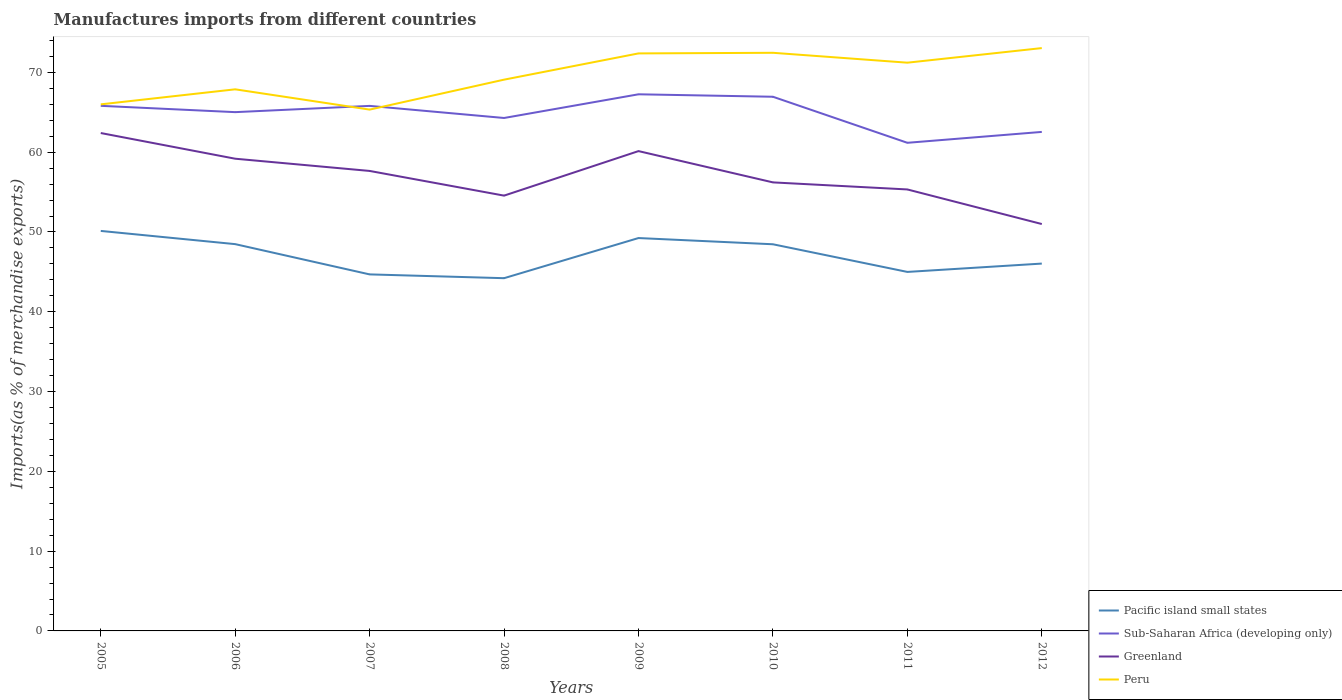Is the number of lines equal to the number of legend labels?
Your response must be concise. Yes. Across all years, what is the maximum percentage of imports to different countries in Greenland?
Offer a very short reply. 51. In which year was the percentage of imports to different countries in Greenland maximum?
Give a very brief answer. 2012. What is the total percentage of imports to different countries in Pacific island small states in the graph?
Provide a short and direct response. -5.03. What is the difference between the highest and the second highest percentage of imports to different countries in Greenland?
Provide a succinct answer. 11.41. How many lines are there?
Your answer should be compact. 4. What is the difference between two consecutive major ticks on the Y-axis?
Your response must be concise. 10. Are the values on the major ticks of Y-axis written in scientific E-notation?
Your response must be concise. No. Does the graph contain any zero values?
Keep it short and to the point. No. Where does the legend appear in the graph?
Make the answer very short. Bottom right. How are the legend labels stacked?
Ensure brevity in your answer.  Vertical. What is the title of the graph?
Give a very brief answer. Manufactures imports from different countries. What is the label or title of the X-axis?
Keep it short and to the point. Years. What is the label or title of the Y-axis?
Your answer should be very brief. Imports(as % of merchandise exports). What is the Imports(as % of merchandise exports) in Pacific island small states in 2005?
Ensure brevity in your answer.  50.13. What is the Imports(as % of merchandise exports) of Sub-Saharan Africa (developing only) in 2005?
Give a very brief answer. 65.81. What is the Imports(as % of merchandise exports) of Greenland in 2005?
Offer a very short reply. 62.4. What is the Imports(as % of merchandise exports) of Peru in 2005?
Provide a succinct answer. 66. What is the Imports(as % of merchandise exports) in Pacific island small states in 2006?
Your response must be concise. 48.48. What is the Imports(as % of merchandise exports) of Sub-Saharan Africa (developing only) in 2006?
Provide a short and direct response. 65.02. What is the Imports(as % of merchandise exports) of Greenland in 2006?
Your answer should be very brief. 59.18. What is the Imports(as % of merchandise exports) in Peru in 2006?
Offer a very short reply. 67.88. What is the Imports(as % of merchandise exports) of Pacific island small states in 2007?
Offer a very short reply. 44.68. What is the Imports(as % of merchandise exports) of Sub-Saharan Africa (developing only) in 2007?
Offer a terse response. 65.8. What is the Imports(as % of merchandise exports) of Greenland in 2007?
Offer a terse response. 57.65. What is the Imports(as % of merchandise exports) in Peru in 2007?
Make the answer very short. 65.34. What is the Imports(as % of merchandise exports) of Pacific island small states in 2008?
Your answer should be compact. 44.21. What is the Imports(as % of merchandise exports) of Sub-Saharan Africa (developing only) in 2008?
Your answer should be compact. 64.29. What is the Imports(as % of merchandise exports) of Greenland in 2008?
Your response must be concise. 54.56. What is the Imports(as % of merchandise exports) of Peru in 2008?
Your answer should be compact. 69.09. What is the Imports(as % of merchandise exports) of Pacific island small states in 2009?
Your answer should be very brief. 49.24. What is the Imports(as % of merchandise exports) of Sub-Saharan Africa (developing only) in 2009?
Ensure brevity in your answer.  67.26. What is the Imports(as % of merchandise exports) of Greenland in 2009?
Offer a terse response. 60.14. What is the Imports(as % of merchandise exports) in Peru in 2009?
Provide a succinct answer. 72.38. What is the Imports(as % of merchandise exports) of Pacific island small states in 2010?
Your answer should be very brief. 48.46. What is the Imports(as % of merchandise exports) in Sub-Saharan Africa (developing only) in 2010?
Provide a succinct answer. 66.95. What is the Imports(as % of merchandise exports) of Greenland in 2010?
Ensure brevity in your answer.  56.22. What is the Imports(as % of merchandise exports) of Peru in 2010?
Provide a succinct answer. 72.46. What is the Imports(as % of merchandise exports) of Pacific island small states in 2011?
Your response must be concise. 44.99. What is the Imports(as % of merchandise exports) of Sub-Saharan Africa (developing only) in 2011?
Keep it short and to the point. 61.18. What is the Imports(as % of merchandise exports) in Greenland in 2011?
Provide a succinct answer. 55.33. What is the Imports(as % of merchandise exports) in Peru in 2011?
Make the answer very short. 71.22. What is the Imports(as % of merchandise exports) in Pacific island small states in 2012?
Give a very brief answer. 46.04. What is the Imports(as % of merchandise exports) in Sub-Saharan Africa (developing only) in 2012?
Your response must be concise. 62.54. What is the Imports(as % of merchandise exports) of Greenland in 2012?
Your answer should be very brief. 51. What is the Imports(as % of merchandise exports) in Peru in 2012?
Give a very brief answer. 73.05. Across all years, what is the maximum Imports(as % of merchandise exports) in Pacific island small states?
Offer a terse response. 50.13. Across all years, what is the maximum Imports(as % of merchandise exports) of Sub-Saharan Africa (developing only)?
Keep it short and to the point. 67.26. Across all years, what is the maximum Imports(as % of merchandise exports) of Greenland?
Make the answer very short. 62.4. Across all years, what is the maximum Imports(as % of merchandise exports) of Peru?
Keep it short and to the point. 73.05. Across all years, what is the minimum Imports(as % of merchandise exports) of Pacific island small states?
Offer a very short reply. 44.21. Across all years, what is the minimum Imports(as % of merchandise exports) of Sub-Saharan Africa (developing only)?
Make the answer very short. 61.18. Across all years, what is the minimum Imports(as % of merchandise exports) of Greenland?
Offer a very short reply. 51. Across all years, what is the minimum Imports(as % of merchandise exports) in Peru?
Your answer should be very brief. 65.34. What is the total Imports(as % of merchandise exports) of Pacific island small states in the graph?
Your response must be concise. 376.24. What is the total Imports(as % of merchandise exports) of Sub-Saharan Africa (developing only) in the graph?
Your response must be concise. 518.85. What is the total Imports(as % of merchandise exports) in Greenland in the graph?
Offer a very short reply. 456.47. What is the total Imports(as % of merchandise exports) of Peru in the graph?
Make the answer very short. 557.41. What is the difference between the Imports(as % of merchandise exports) of Pacific island small states in 2005 and that in 2006?
Ensure brevity in your answer.  1.66. What is the difference between the Imports(as % of merchandise exports) in Sub-Saharan Africa (developing only) in 2005 and that in 2006?
Offer a terse response. 0.79. What is the difference between the Imports(as % of merchandise exports) in Greenland in 2005 and that in 2006?
Give a very brief answer. 3.22. What is the difference between the Imports(as % of merchandise exports) of Peru in 2005 and that in 2006?
Offer a terse response. -1.88. What is the difference between the Imports(as % of merchandise exports) in Pacific island small states in 2005 and that in 2007?
Your answer should be very brief. 5.45. What is the difference between the Imports(as % of merchandise exports) of Sub-Saharan Africa (developing only) in 2005 and that in 2007?
Your answer should be compact. 0.01. What is the difference between the Imports(as % of merchandise exports) in Greenland in 2005 and that in 2007?
Offer a very short reply. 4.75. What is the difference between the Imports(as % of merchandise exports) of Peru in 2005 and that in 2007?
Provide a succinct answer. 0.66. What is the difference between the Imports(as % of merchandise exports) in Pacific island small states in 2005 and that in 2008?
Provide a succinct answer. 5.92. What is the difference between the Imports(as % of merchandise exports) of Sub-Saharan Africa (developing only) in 2005 and that in 2008?
Ensure brevity in your answer.  1.52. What is the difference between the Imports(as % of merchandise exports) of Greenland in 2005 and that in 2008?
Offer a terse response. 7.85. What is the difference between the Imports(as % of merchandise exports) in Peru in 2005 and that in 2008?
Offer a terse response. -3.1. What is the difference between the Imports(as % of merchandise exports) in Pacific island small states in 2005 and that in 2009?
Give a very brief answer. 0.89. What is the difference between the Imports(as % of merchandise exports) in Sub-Saharan Africa (developing only) in 2005 and that in 2009?
Your response must be concise. -1.45. What is the difference between the Imports(as % of merchandise exports) of Greenland in 2005 and that in 2009?
Provide a short and direct response. 2.26. What is the difference between the Imports(as % of merchandise exports) in Peru in 2005 and that in 2009?
Provide a short and direct response. -6.39. What is the difference between the Imports(as % of merchandise exports) of Pacific island small states in 2005 and that in 2010?
Your response must be concise. 1.67. What is the difference between the Imports(as % of merchandise exports) in Sub-Saharan Africa (developing only) in 2005 and that in 2010?
Your response must be concise. -1.14. What is the difference between the Imports(as % of merchandise exports) of Greenland in 2005 and that in 2010?
Your answer should be compact. 6.19. What is the difference between the Imports(as % of merchandise exports) of Peru in 2005 and that in 2010?
Your answer should be very brief. -6.46. What is the difference between the Imports(as % of merchandise exports) of Pacific island small states in 2005 and that in 2011?
Your response must be concise. 5.14. What is the difference between the Imports(as % of merchandise exports) in Sub-Saharan Africa (developing only) in 2005 and that in 2011?
Keep it short and to the point. 4.63. What is the difference between the Imports(as % of merchandise exports) of Greenland in 2005 and that in 2011?
Offer a very short reply. 7.07. What is the difference between the Imports(as % of merchandise exports) in Peru in 2005 and that in 2011?
Give a very brief answer. -5.22. What is the difference between the Imports(as % of merchandise exports) in Pacific island small states in 2005 and that in 2012?
Offer a very short reply. 4.09. What is the difference between the Imports(as % of merchandise exports) in Sub-Saharan Africa (developing only) in 2005 and that in 2012?
Offer a terse response. 3.27. What is the difference between the Imports(as % of merchandise exports) of Greenland in 2005 and that in 2012?
Provide a short and direct response. 11.41. What is the difference between the Imports(as % of merchandise exports) of Peru in 2005 and that in 2012?
Make the answer very short. -7.05. What is the difference between the Imports(as % of merchandise exports) in Pacific island small states in 2006 and that in 2007?
Give a very brief answer. 3.79. What is the difference between the Imports(as % of merchandise exports) in Sub-Saharan Africa (developing only) in 2006 and that in 2007?
Provide a succinct answer. -0.78. What is the difference between the Imports(as % of merchandise exports) of Greenland in 2006 and that in 2007?
Make the answer very short. 1.53. What is the difference between the Imports(as % of merchandise exports) in Peru in 2006 and that in 2007?
Offer a very short reply. 2.54. What is the difference between the Imports(as % of merchandise exports) of Pacific island small states in 2006 and that in 2008?
Your response must be concise. 4.27. What is the difference between the Imports(as % of merchandise exports) in Sub-Saharan Africa (developing only) in 2006 and that in 2008?
Offer a terse response. 0.73. What is the difference between the Imports(as % of merchandise exports) of Greenland in 2006 and that in 2008?
Provide a succinct answer. 4.63. What is the difference between the Imports(as % of merchandise exports) in Peru in 2006 and that in 2008?
Ensure brevity in your answer.  -1.21. What is the difference between the Imports(as % of merchandise exports) in Pacific island small states in 2006 and that in 2009?
Provide a short and direct response. -0.76. What is the difference between the Imports(as % of merchandise exports) of Sub-Saharan Africa (developing only) in 2006 and that in 2009?
Provide a short and direct response. -2.24. What is the difference between the Imports(as % of merchandise exports) in Greenland in 2006 and that in 2009?
Your answer should be very brief. -0.95. What is the difference between the Imports(as % of merchandise exports) in Peru in 2006 and that in 2009?
Offer a very short reply. -4.5. What is the difference between the Imports(as % of merchandise exports) of Pacific island small states in 2006 and that in 2010?
Your answer should be compact. 0.02. What is the difference between the Imports(as % of merchandise exports) of Sub-Saharan Africa (developing only) in 2006 and that in 2010?
Make the answer very short. -1.93. What is the difference between the Imports(as % of merchandise exports) in Greenland in 2006 and that in 2010?
Provide a short and direct response. 2.97. What is the difference between the Imports(as % of merchandise exports) in Peru in 2006 and that in 2010?
Keep it short and to the point. -4.58. What is the difference between the Imports(as % of merchandise exports) of Pacific island small states in 2006 and that in 2011?
Make the answer very short. 3.48. What is the difference between the Imports(as % of merchandise exports) in Sub-Saharan Africa (developing only) in 2006 and that in 2011?
Provide a succinct answer. 3.84. What is the difference between the Imports(as % of merchandise exports) in Greenland in 2006 and that in 2011?
Your answer should be very brief. 3.85. What is the difference between the Imports(as % of merchandise exports) of Peru in 2006 and that in 2011?
Offer a terse response. -3.34. What is the difference between the Imports(as % of merchandise exports) in Pacific island small states in 2006 and that in 2012?
Provide a succinct answer. 2.44. What is the difference between the Imports(as % of merchandise exports) in Sub-Saharan Africa (developing only) in 2006 and that in 2012?
Provide a short and direct response. 2.48. What is the difference between the Imports(as % of merchandise exports) of Greenland in 2006 and that in 2012?
Offer a very short reply. 8.19. What is the difference between the Imports(as % of merchandise exports) of Peru in 2006 and that in 2012?
Your response must be concise. -5.17. What is the difference between the Imports(as % of merchandise exports) of Pacific island small states in 2007 and that in 2008?
Your answer should be very brief. 0.47. What is the difference between the Imports(as % of merchandise exports) of Sub-Saharan Africa (developing only) in 2007 and that in 2008?
Provide a short and direct response. 1.52. What is the difference between the Imports(as % of merchandise exports) in Greenland in 2007 and that in 2008?
Provide a short and direct response. 3.09. What is the difference between the Imports(as % of merchandise exports) of Peru in 2007 and that in 2008?
Offer a very short reply. -3.75. What is the difference between the Imports(as % of merchandise exports) of Pacific island small states in 2007 and that in 2009?
Keep it short and to the point. -4.56. What is the difference between the Imports(as % of merchandise exports) in Sub-Saharan Africa (developing only) in 2007 and that in 2009?
Ensure brevity in your answer.  -1.45. What is the difference between the Imports(as % of merchandise exports) of Greenland in 2007 and that in 2009?
Your answer should be compact. -2.49. What is the difference between the Imports(as % of merchandise exports) of Peru in 2007 and that in 2009?
Offer a terse response. -7.04. What is the difference between the Imports(as % of merchandise exports) in Pacific island small states in 2007 and that in 2010?
Your answer should be compact. -3.78. What is the difference between the Imports(as % of merchandise exports) in Sub-Saharan Africa (developing only) in 2007 and that in 2010?
Your answer should be very brief. -1.14. What is the difference between the Imports(as % of merchandise exports) in Greenland in 2007 and that in 2010?
Your answer should be compact. 1.43. What is the difference between the Imports(as % of merchandise exports) of Peru in 2007 and that in 2010?
Ensure brevity in your answer.  -7.12. What is the difference between the Imports(as % of merchandise exports) in Pacific island small states in 2007 and that in 2011?
Offer a terse response. -0.31. What is the difference between the Imports(as % of merchandise exports) in Sub-Saharan Africa (developing only) in 2007 and that in 2011?
Give a very brief answer. 4.63. What is the difference between the Imports(as % of merchandise exports) in Greenland in 2007 and that in 2011?
Offer a very short reply. 2.32. What is the difference between the Imports(as % of merchandise exports) in Peru in 2007 and that in 2011?
Give a very brief answer. -5.88. What is the difference between the Imports(as % of merchandise exports) of Pacific island small states in 2007 and that in 2012?
Provide a succinct answer. -1.36. What is the difference between the Imports(as % of merchandise exports) of Sub-Saharan Africa (developing only) in 2007 and that in 2012?
Your answer should be compact. 3.26. What is the difference between the Imports(as % of merchandise exports) of Greenland in 2007 and that in 2012?
Your answer should be very brief. 6.65. What is the difference between the Imports(as % of merchandise exports) in Peru in 2007 and that in 2012?
Offer a terse response. -7.71. What is the difference between the Imports(as % of merchandise exports) in Pacific island small states in 2008 and that in 2009?
Keep it short and to the point. -5.03. What is the difference between the Imports(as % of merchandise exports) in Sub-Saharan Africa (developing only) in 2008 and that in 2009?
Provide a short and direct response. -2.97. What is the difference between the Imports(as % of merchandise exports) in Greenland in 2008 and that in 2009?
Offer a very short reply. -5.58. What is the difference between the Imports(as % of merchandise exports) in Peru in 2008 and that in 2009?
Make the answer very short. -3.29. What is the difference between the Imports(as % of merchandise exports) of Pacific island small states in 2008 and that in 2010?
Offer a terse response. -4.25. What is the difference between the Imports(as % of merchandise exports) of Sub-Saharan Africa (developing only) in 2008 and that in 2010?
Provide a succinct answer. -2.66. What is the difference between the Imports(as % of merchandise exports) in Greenland in 2008 and that in 2010?
Give a very brief answer. -1.66. What is the difference between the Imports(as % of merchandise exports) of Peru in 2008 and that in 2010?
Give a very brief answer. -3.37. What is the difference between the Imports(as % of merchandise exports) in Pacific island small states in 2008 and that in 2011?
Make the answer very short. -0.79. What is the difference between the Imports(as % of merchandise exports) of Sub-Saharan Africa (developing only) in 2008 and that in 2011?
Your response must be concise. 3.11. What is the difference between the Imports(as % of merchandise exports) of Greenland in 2008 and that in 2011?
Provide a succinct answer. -0.77. What is the difference between the Imports(as % of merchandise exports) in Peru in 2008 and that in 2011?
Make the answer very short. -2.13. What is the difference between the Imports(as % of merchandise exports) in Pacific island small states in 2008 and that in 2012?
Your response must be concise. -1.83. What is the difference between the Imports(as % of merchandise exports) in Sub-Saharan Africa (developing only) in 2008 and that in 2012?
Ensure brevity in your answer.  1.75. What is the difference between the Imports(as % of merchandise exports) in Greenland in 2008 and that in 2012?
Give a very brief answer. 3.56. What is the difference between the Imports(as % of merchandise exports) of Peru in 2008 and that in 2012?
Provide a short and direct response. -3.96. What is the difference between the Imports(as % of merchandise exports) of Pacific island small states in 2009 and that in 2010?
Your answer should be compact. 0.78. What is the difference between the Imports(as % of merchandise exports) of Sub-Saharan Africa (developing only) in 2009 and that in 2010?
Keep it short and to the point. 0.31. What is the difference between the Imports(as % of merchandise exports) of Greenland in 2009 and that in 2010?
Ensure brevity in your answer.  3.92. What is the difference between the Imports(as % of merchandise exports) of Peru in 2009 and that in 2010?
Make the answer very short. -0.08. What is the difference between the Imports(as % of merchandise exports) of Pacific island small states in 2009 and that in 2011?
Keep it short and to the point. 4.25. What is the difference between the Imports(as % of merchandise exports) in Sub-Saharan Africa (developing only) in 2009 and that in 2011?
Offer a terse response. 6.08. What is the difference between the Imports(as % of merchandise exports) in Greenland in 2009 and that in 2011?
Your response must be concise. 4.81. What is the difference between the Imports(as % of merchandise exports) in Peru in 2009 and that in 2011?
Give a very brief answer. 1.16. What is the difference between the Imports(as % of merchandise exports) of Pacific island small states in 2009 and that in 2012?
Keep it short and to the point. 3.2. What is the difference between the Imports(as % of merchandise exports) of Sub-Saharan Africa (developing only) in 2009 and that in 2012?
Your answer should be very brief. 4.72. What is the difference between the Imports(as % of merchandise exports) in Greenland in 2009 and that in 2012?
Your answer should be very brief. 9.14. What is the difference between the Imports(as % of merchandise exports) in Peru in 2009 and that in 2012?
Offer a terse response. -0.67. What is the difference between the Imports(as % of merchandise exports) of Pacific island small states in 2010 and that in 2011?
Make the answer very short. 3.47. What is the difference between the Imports(as % of merchandise exports) of Sub-Saharan Africa (developing only) in 2010 and that in 2011?
Your answer should be compact. 5.77. What is the difference between the Imports(as % of merchandise exports) in Greenland in 2010 and that in 2011?
Your response must be concise. 0.88. What is the difference between the Imports(as % of merchandise exports) in Peru in 2010 and that in 2011?
Ensure brevity in your answer.  1.24. What is the difference between the Imports(as % of merchandise exports) in Pacific island small states in 2010 and that in 2012?
Ensure brevity in your answer.  2.42. What is the difference between the Imports(as % of merchandise exports) of Sub-Saharan Africa (developing only) in 2010 and that in 2012?
Provide a succinct answer. 4.41. What is the difference between the Imports(as % of merchandise exports) in Greenland in 2010 and that in 2012?
Ensure brevity in your answer.  5.22. What is the difference between the Imports(as % of merchandise exports) in Peru in 2010 and that in 2012?
Give a very brief answer. -0.59. What is the difference between the Imports(as % of merchandise exports) in Pacific island small states in 2011 and that in 2012?
Your answer should be very brief. -1.05. What is the difference between the Imports(as % of merchandise exports) in Sub-Saharan Africa (developing only) in 2011 and that in 2012?
Your answer should be very brief. -1.36. What is the difference between the Imports(as % of merchandise exports) in Greenland in 2011 and that in 2012?
Ensure brevity in your answer.  4.33. What is the difference between the Imports(as % of merchandise exports) of Peru in 2011 and that in 2012?
Your response must be concise. -1.83. What is the difference between the Imports(as % of merchandise exports) in Pacific island small states in 2005 and the Imports(as % of merchandise exports) in Sub-Saharan Africa (developing only) in 2006?
Provide a short and direct response. -14.89. What is the difference between the Imports(as % of merchandise exports) in Pacific island small states in 2005 and the Imports(as % of merchandise exports) in Greenland in 2006?
Keep it short and to the point. -9.05. What is the difference between the Imports(as % of merchandise exports) in Pacific island small states in 2005 and the Imports(as % of merchandise exports) in Peru in 2006?
Keep it short and to the point. -17.75. What is the difference between the Imports(as % of merchandise exports) of Sub-Saharan Africa (developing only) in 2005 and the Imports(as % of merchandise exports) of Greenland in 2006?
Keep it short and to the point. 6.63. What is the difference between the Imports(as % of merchandise exports) in Sub-Saharan Africa (developing only) in 2005 and the Imports(as % of merchandise exports) in Peru in 2006?
Keep it short and to the point. -2.07. What is the difference between the Imports(as % of merchandise exports) of Greenland in 2005 and the Imports(as % of merchandise exports) of Peru in 2006?
Provide a short and direct response. -5.48. What is the difference between the Imports(as % of merchandise exports) in Pacific island small states in 2005 and the Imports(as % of merchandise exports) in Sub-Saharan Africa (developing only) in 2007?
Offer a very short reply. -15.67. What is the difference between the Imports(as % of merchandise exports) of Pacific island small states in 2005 and the Imports(as % of merchandise exports) of Greenland in 2007?
Your answer should be compact. -7.52. What is the difference between the Imports(as % of merchandise exports) in Pacific island small states in 2005 and the Imports(as % of merchandise exports) in Peru in 2007?
Make the answer very short. -15.21. What is the difference between the Imports(as % of merchandise exports) in Sub-Saharan Africa (developing only) in 2005 and the Imports(as % of merchandise exports) in Greenland in 2007?
Provide a short and direct response. 8.16. What is the difference between the Imports(as % of merchandise exports) of Sub-Saharan Africa (developing only) in 2005 and the Imports(as % of merchandise exports) of Peru in 2007?
Provide a succinct answer. 0.47. What is the difference between the Imports(as % of merchandise exports) in Greenland in 2005 and the Imports(as % of merchandise exports) in Peru in 2007?
Ensure brevity in your answer.  -2.94. What is the difference between the Imports(as % of merchandise exports) of Pacific island small states in 2005 and the Imports(as % of merchandise exports) of Sub-Saharan Africa (developing only) in 2008?
Your answer should be very brief. -14.15. What is the difference between the Imports(as % of merchandise exports) of Pacific island small states in 2005 and the Imports(as % of merchandise exports) of Greenland in 2008?
Your answer should be compact. -4.42. What is the difference between the Imports(as % of merchandise exports) of Pacific island small states in 2005 and the Imports(as % of merchandise exports) of Peru in 2008?
Make the answer very short. -18.96. What is the difference between the Imports(as % of merchandise exports) in Sub-Saharan Africa (developing only) in 2005 and the Imports(as % of merchandise exports) in Greenland in 2008?
Give a very brief answer. 11.26. What is the difference between the Imports(as % of merchandise exports) of Sub-Saharan Africa (developing only) in 2005 and the Imports(as % of merchandise exports) of Peru in 2008?
Provide a short and direct response. -3.28. What is the difference between the Imports(as % of merchandise exports) of Greenland in 2005 and the Imports(as % of merchandise exports) of Peru in 2008?
Provide a short and direct response. -6.69. What is the difference between the Imports(as % of merchandise exports) in Pacific island small states in 2005 and the Imports(as % of merchandise exports) in Sub-Saharan Africa (developing only) in 2009?
Offer a terse response. -17.12. What is the difference between the Imports(as % of merchandise exports) in Pacific island small states in 2005 and the Imports(as % of merchandise exports) in Greenland in 2009?
Give a very brief answer. -10. What is the difference between the Imports(as % of merchandise exports) in Pacific island small states in 2005 and the Imports(as % of merchandise exports) in Peru in 2009?
Provide a short and direct response. -22.25. What is the difference between the Imports(as % of merchandise exports) in Sub-Saharan Africa (developing only) in 2005 and the Imports(as % of merchandise exports) in Greenland in 2009?
Make the answer very short. 5.67. What is the difference between the Imports(as % of merchandise exports) in Sub-Saharan Africa (developing only) in 2005 and the Imports(as % of merchandise exports) in Peru in 2009?
Provide a short and direct response. -6.57. What is the difference between the Imports(as % of merchandise exports) of Greenland in 2005 and the Imports(as % of merchandise exports) of Peru in 2009?
Provide a short and direct response. -9.98. What is the difference between the Imports(as % of merchandise exports) of Pacific island small states in 2005 and the Imports(as % of merchandise exports) of Sub-Saharan Africa (developing only) in 2010?
Provide a short and direct response. -16.82. What is the difference between the Imports(as % of merchandise exports) in Pacific island small states in 2005 and the Imports(as % of merchandise exports) in Greenland in 2010?
Give a very brief answer. -6.08. What is the difference between the Imports(as % of merchandise exports) of Pacific island small states in 2005 and the Imports(as % of merchandise exports) of Peru in 2010?
Provide a succinct answer. -22.33. What is the difference between the Imports(as % of merchandise exports) in Sub-Saharan Africa (developing only) in 2005 and the Imports(as % of merchandise exports) in Greenland in 2010?
Make the answer very short. 9.6. What is the difference between the Imports(as % of merchandise exports) of Sub-Saharan Africa (developing only) in 2005 and the Imports(as % of merchandise exports) of Peru in 2010?
Make the answer very short. -6.65. What is the difference between the Imports(as % of merchandise exports) of Greenland in 2005 and the Imports(as % of merchandise exports) of Peru in 2010?
Make the answer very short. -10.06. What is the difference between the Imports(as % of merchandise exports) in Pacific island small states in 2005 and the Imports(as % of merchandise exports) in Sub-Saharan Africa (developing only) in 2011?
Provide a short and direct response. -11.04. What is the difference between the Imports(as % of merchandise exports) in Pacific island small states in 2005 and the Imports(as % of merchandise exports) in Greenland in 2011?
Your response must be concise. -5.2. What is the difference between the Imports(as % of merchandise exports) of Pacific island small states in 2005 and the Imports(as % of merchandise exports) of Peru in 2011?
Give a very brief answer. -21.09. What is the difference between the Imports(as % of merchandise exports) of Sub-Saharan Africa (developing only) in 2005 and the Imports(as % of merchandise exports) of Greenland in 2011?
Your answer should be compact. 10.48. What is the difference between the Imports(as % of merchandise exports) of Sub-Saharan Africa (developing only) in 2005 and the Imports(as % of merchandise exports) of Peru in 2011?
Give a very brief answer. -5.41. What is the difference between the Imports(as % of merchandise exports) in Greenland in 2005 and the Imports(as % of merchandise exports) in Peru in 2011?
Provide a succinct answer. -8.82. What is the difference between the Imports(as % of merchandise exports) of Pacific island small states in 2005 and the Imports(as % of merchandise exports) of Sub-Saharan Africa (developing only) in 2012?
Offer a terse response. -12.41. What is the difference between the Imports(as % of merchandise exports) in Pacific island small states in 2005 and the Imports(as % of merchandise exports) in Greenland in 2012?
Provide a succinct answer. -0.86. What is the difference between the Imports(as % of merchandise exports) of Pacific island small states in 2005 and the Imports(as % of merchandise exports) of Peru in 2012?
Your answer should be compact. -22.92. What is the difference between the Imports(as % of merchandise exports) in Sub-Saharan Africa (developing only) in 2005 and the Imports(as % of merchandise exports) in Greenland in 2012?
Offer a terse response. 14.82. What is the difference between the Imports(as % of merchandise exports) of Sub-Saharan Africa (developing only) in 2005 and the Imports(as % of merchandise exports) of Peru in 2012?
Provide a short and direct response. -7.24. What is the difference between the Imports(as % of merchandise exports) in Greenland in 2005 and the Imports(as % of merchandise exports) in Peru in 2012?
Make the answer very short. -10.65. What is the difference between the Imports(as % of merchandise exports) in Pacific island small states in 2006 and the Imports(as % of merchandise exports) in Sub-Saharan Africa (developing only) in 2007?
Your answer should be very brief. -17.33. What is the difference between the Imports(as % of merchandise exports) in Pacific island small states in 2006 and the Imports(as % of merchandise exports) in Greenland in 2007?
Provide a succinct answer. -9.17. What is the difference between the Imports(as % of merchandise exports) of Pacific island small states in 2006 and the Imports(as % of merchandise exports) of Peru in 2007?
Offer a terse response. -16.86. What is the difference between the Imports(as % of merchandise exports) of Sub-Saharan Africa (developing only) in 2006 and the Imports(as % of merchandise exports) of Greenland in 2007?
Your answer should be compact. 7.37. What is the difference between the Imports(as % of merchandise exports) in Sub-Saharan Africa (developing only) in 2006 and the Imports(as % of merchandise exports) in Peru in 2007?
Provide a short and direct response. -0.32. What is the difference between the Imports(as % of merchandise exports) in Greenland in 2006 and the Imports(as % of merchandise exports) in Peru in 2007?
Give a very brief answer. -6.15. What is the difference between the Imports(as % of merchandise exports) in Pacific island small states in 2006 and the Imports(as % of merchandise exports) in Sub-Saharan Africa (developing only) in 2008?
Offer a very short reply. -15.81. What is the difference between the Imports(as % of merchandise exports) in Pacific island small states in 2006 and the Imports(as % of merchandise exports) in Greenland in 2008?
Keep it short and to the point. -6.08. What is the difference between the Imports(as % of merchandise exports) of Pacific island small states in 2006 and the Imports(as % of merchandise exports) of Peru in 2008?
Ensure brevity in your answer.  -20.61. What is the difference between the Imports(as % of merchandise exports) in Sub-Saharan Africa (developing only) in 2006 and the Imports(as % of merchandise exports) in Greenland in 2008?
Your response must be concise. 10.46. What is the difference between the Imports(as % of merchandise exports) of Sub-Saharan Africa (developing only) in 2006 and the Imports(as % of merchandise exports) of Peru in 2008?
Provide a succinct answer. -4.07. What is the difference between the Imports(as % of merchandise exports) in Greenland in 2006 and the Imports(as % of merchandise exports) in Peru in 2008?
Give a very brief answer. -9.91. What is the difference between the Imports(as % of merchandise exports) in Pacific island small states in 2006 and the Imports(as % of merchandise exports) in Sub-Saharan Africa (developing only) in 2009?
Give a very brief answer. -18.78. What is the difference between the Imports(as % of merchandise exports) in Pacific island small states in 2006 and the Imports(as % of merchandise exports) in Greenland in 2009?
Give a very brief answer. -11.66. What is the difference between the Imports(as % of merchandise exports) of Pacific island small states in 2006 and the Imports(as % of merchandise exports) of Peru in 2009?
Offer a very short reply. -23.9. What is the difference between the Imports(as % of merchandise exports) of Sub-Saharan Africa (developing only) in 2006 and the Imports(as % of merchandise exports) of Greenland in 2009?
Make the answer very short. 4.88. What is the difference between the Imports(as % of merchandise exports) of Sub-Saharan Africa (developing only) in 2006 and the Imports(as % of merchandise exports) of Peru in 2009?
Keep it short and to the point. -7.36. What is the difference between the Imports(as % of merchandise exports) of Greenland in 2006 and the Imports(as % of merchandise exports) of Peru in 2009?
Your response must be concise. -13.2. What is the difference between the Imports(as % of merchandise exports) in Pacific island small states in 2006 and the Imports(as % of merchandise exports) in Sub-Saharan Africa (developing only) in 2010?
Ensure brevity in your answer.  -18.47. What is the difference between the Imports(as % of merchandise exports) of Pacific island small states in 2006 and the Imports(as % of merchandise exports) of Greenland in 2010?
Make the answer very short. -7.74. What is the difference between the Imports(as % of merchandise exports) in Pacific island small states in 2006 and the Imports(as % of merchandise exports) in Peru in 2010?
Keep it short and to the point. -23.98. What is the difference between the Imports(as % of merchandise exports) of Sub-Saharan Africa (developing only) in 2006 and the Imports(as % of merchandise exports) of Greenland in 2010?
Your answer should be compact. 8.8. What is the difference between the Imports(as % of merchandise exports) in Sub-Saharan Africa (developing only) in 2006 and the Imports(as % of merchandise exports) in Peru in 2010?
Ensure brevity in your answer.  -7.44. What is the difference between the Imports(as % of merchandise exports) in Greenland in 2006 and the Imports(as % of merchandise exports) in Peru in 2010?
Ensure brevity in your answer.  -13.28. What is the difference between the Imports(as % of merchandise exports) of Pacific island small states in 2006 and the Imports(as % of merchandise exports) of Sub-Saharan Africa (developing only) in 2011?
Your answer should be compact. -12.7. What is the difference between the Imports(as % of merchandise exports) of Pacific island small states in 2006 and the Imports(as % of merchandise exports) of Greenland in 2011?
Offer a terse response. -6.85. What is the difference between the Imports(as % of merchandise exports) of Pacific island small states in 2006 and the Imports(as % of merchandise exports) of Peru in 2011?
Your response must be concise. -22.74. What is the difference between the Imports(as % of merchandise exports) of Sub-Saharan Africa (developing only) in 2006 and the Imports(as % of merchandise exports) of Greenland in 2011?
Offer a very short reply. 9.69. What is the difference between the Imports(as % of merchandise exports) of Sub-Saharan Africa (developing only) in 2006 and the Imports(as % of merchandise exports) of Peru in 2011?
Your response must be concise. -6.2. What is the difference between the Imports(as % of merchandise exports) in Greenland in 2006 and the Imports(as % of merchandise exports) in Peru in 2011?
Make the answer very short. -12.04. What is the difference between the Imports(as % of merchandise exports) in Pacific island small states in 2006 and the Imports(as % of merchandise exports) in Sub-Saharan Africa (developing only) in 2012?
Provide a succinct answer. -14.06. What is the difference between the Imports(as % of merchandise exports) in Pacific island small states in 2006 and the Imports(as % of merchandise exports) in Greenland in 2012?
Make the answer very short. -2.52. What is the difference between the Imports(as % of merchandise exports) of Pacific island small states in 2006 and the Imports(as % of merchandise exports) of Peru in 2012?
Make the answer very short. -24.57. What is the difference between the Imports(as % of merchandise exports) of Sub-Saharan Africa (developing only) in 2006 and the Imports(as % of merchandise exports) of Greenland in 2012?
Offer a terse response. 14.02. What is the difference between the Imports(as % of merchandise exports) of Sub-Saharan Africa (developing only) in 2006 and the Imports(as % of merchandise exports) of Peru in 2012?
Provide a short and direct response. -8.03. What is the difference between the Imports(as % of merchandise exports) of Greenland in 2006 and the Imports(as % of merchandise exports) of Peru in 2012?
Ensure brevity in your answer.  -13.87. What is the difference between the Imports(as % of merchandise exports) of Pacific island small states in 2007 and the Imports(as % of merchandise exports) of Sub-Saharan Africa (developing only) in 2008?
Give a very brief answer. -19.6. What is the difference between the Imports(as % of merchandise exports) in Pacific island small states in 2007 and the Imports(as % of merchandise exports) in Greenland in 2008?
Your answer should be very brief. -9.87. What is the difference between the Imports(as % of merchandise exports) of Pacific island small states in 2007 and the Imports(as % of merchandise exports) of Peru in 2008?
Your answer should be compact. -24.41. What is the difference between the Imports(as % of merchandise exports) of Sub-Saharan Africa (developing only) in 2007 and the Imports(as % of merchandise exports) of Greenland in 2008?
Offer a very short reply. 11.25. What is the difference between the Imports(as % of merchandise exports) of Sub-Saharan Africa (developing only) in 2007 and the Imports(as % of merchandise exports) of Peru in 2008?
Give a very brief answer. -3.29. What is the difference between the Imports(as % of merchandise exports) in Greenland in 2007 and the Imports(as % of merchandise exports) in Peru in 2008?
Your answer should be compact. -11.44. What is the difference between the Imports(as % of merchandise exports) of Pacific island small states in 2007 and the Imports(as % of merchandise exports) of Sub-Saharan Africa (developing only) in 2009?
Provide a short and direct response. -22.57. What is the difference between the Imports(as % of merchandise exports) in Pacific island small states in 2007 and the Imports(as % of merchandise exports) in Greenland in 2009?
Provide a succinct answer. -15.45. What is the difference between the Imports(as % of merchandise exports) in Pacific island small states in 2007 and the Imports(as % of merchandise exports) in Peru in 2009?
Your answer should be very brief. -27.7. What is the difference between the Imports(as % of merchandise exports) in Sub-Saharan Africa (developing only) in 2007 and the Imports(as % of merchandise exports) in Greenland in 2009?
Your response must be concise. 5.67. What is the difference between the Imports(as % of merchandise exports) of Sub-Saharan Africa (developing only) in 2007 and the Imports(as % of merchandise exports) of Peru in 2009?
Offer a very short reply. -6.58. What is the difference between the Imports(as % of merchandise exports) of Greenland in 2007 and the Imports(as % of merchandise exports) of Peru in 2009?
Give a very brief answer. -14.73. What is the difference between the Imports(as % of merchandise exports) of Pacific island small states in 2007 and the Imports(as % of merchandise exports) of Sub-Saharan Africa (developing only) in 2010?
Provide a succinct answer. -22.26. What is the difference between the Imports(as % of merchandise exports) in Pacific island small states in 2007 and the Imports(as % of merchandise exports) in Greenland in 2010?
Your answer should be compact. -11.53. What is the difference between the Imports(as % of merchandise exports) in Pacific island small states in 2007 and the Imports(as % of merchandise exports) in Peru in 2010?
Make the answer very short. -27.77. What is the difference between the Imports(as % of merchandise exports) of Sub-Saharan Africa (developing only) in 2007 and the Imports(as % of merchandise exports) of Greenland in 2010?
Offer a terse response. 9.59. What is the difference between the Imports(as % of merchandise exports) in Sub-Saharan Africa (developing only) in 2007 and the Imports(as % of merchandise exports) in Peru in 2010?
Your response must be concise. -6.65. What is the difference between the Imports(as % of merchandise exports) of Greenland in 2007 and the Imports(as % of merchandise exports) of Peru in 2010?
Your response must be concise. -14.81. What is the difference between the Imports(as % of merchandise exports) in Pacific island small states in 2007 and the Imports(as % of merchandise exports) in Sub-Saharan Africa (developing only) in 2011?
Provide a succinct answer. -16.49. What is the difference between the Imports(as % of merchandise exports) in Pacific island small states in 2007 and the Imports(as % of merchandise exports) in Greenland in 2011?
Make the answer very short. -10.65. What is the difference between the Imports(as % of merchandise exports) in Pacific island small states in 2007 and the Imports(as % of merchandise exports) in Peru in 2011?
Make the answer very short. -26.53. What is the difference between the Imports(as % of merchandise exports) in Sub-Saharan Africa (developing only) in 2007 and the Imports(as % of merchandise exports) in Greenland in 2011?
Offer a terse response. 10.47. What is the difference between the Imports(as % of merchandise exports) in Sub-Saharan Africa (developing only) in 2007 and the Imports(as % of merchandise exports) in Peru in 2011?
Your response must be concise. -5.41. What is the difference between the Imports(as % of merchandise exports) in Greenland in 2007 and the Imports(as % of merchandise exports) in Peru in 2011?
Offer a terse response. -13.57. What is the difference between the Imports(as % of merchandise exports) of Pacific island small states in 2007 and the Imports(as % of merchandise exports) of Sub-Saharan Africa (developing only) in 2012?
Offer a terse response. -17.86. What is the difference between the Imports(as % of merchandise exports) of Pacific island small states in 2007 and the Imports(as % of merchandise exports) of Greenland in 2012?
Offer a terse response. -6.31. What is the difference between the Imports(as % of merchandise exports) in Pacific island small states in 2007 and the Imports(as % of merchandise exports) in Peru in 2012?
Provide a short and direct response. -28.36. What is the difference between the Imports(as % of merchandise exports) in Sub-Saharan Africa (developing only) in 2007 and the Imports(as % of merchandise exports) in Greenland in 2012?
Your response must be concise. 14.81. What is the difference between the Imports(as % of merchandise exports) of Sub-Saharan Africa (developing only) in 2007 and the Imports(as % of merchandise exports) of Peru in 2012?
Provide a succinct answer. -7.24. What is the difference between the Imports(as % of merchandise exports) of Greenland in 2007 and the Imports(as % of merchandise exports) of Peru in 2012?
Your response must be concise. -15.4. What is the difference between the Imports(as % of merchandise exports) of Pacific island small states in 2008 and the Imports(as % of merchandise exports) of Sub-Saharan Africa (developing only) in 2009?
Provide a short and direct response. -23.05. What is the difference between the Imports(as % of merchandise exports) in Pacific island small states in 2008 and the Imports(as % of merchandise exports) in Greenland in 2009?
Give a very brief answer. -15.93. What is the difference between the Imports(as % of merchandise exports) of Pacific island small states in 2008 and the Imports(as % of merchandise exports) of Peru in 2009?
Give a very brief answer. -28.17. What is the difference between the Imports(as % of merchandise exports) in Sub-Saharan Africa (developing only) in 2008 and the Imports(as % of merchandise exports) in Greenland in 2009?
Offer a very short reply. 4.15. What is the difference between the Imports(as % of merchandise exports) in Sub-Saharan Africa (developing only) in 2008 and the Imports(as % of merchandise exports) in Peru in 2009?
Provide a succinct answer. -8.09. What is the difference between the Imports(as % of merchandise exports) of Greenland in 2008 and the Imports(as % of merchandise exports) of Peru in 2009?
Make the answer very short. -17.83. What is the difference between the Imports(as % of merchandise exports) of Pacific island small states in 2008 and the Imports(as % of merchandise exports) of Sub-Saharan Africa (developing only) in 2010?
Keep it short and to the point. -22.74. What is the difference between the Imports(as % of merchandise exports) in Pacific island small states in 2008 and the Imports(as % of merchandise exports) in Greenland in 2010?
Provide a succinct answer. -12.01. What is the difference between the Imports(as % of merchandise exports) of Pacific island small states in 2008 and the Imports(as % of merchandise exports) of Peru in 2010?
Your answer should be compact. -28.25. What is the difference between the Imports(as % of merchandise exports) of Sub-Saharan Africa (developing only) in 2008 and the Imports(as % of merchandise exports) of Greenland in 2010?
Give a very brief answer. 8.07. What is the difference between the Imports(as % of merchandise exports) of Sub-Saharan Africa (developing only) in 2008 and the Imports(as % of merchandise exports) of Peru in 2010?
Your answer should be compact. -8.17. What is the difference between the Imports(as % of merchandise exports) in Greenland in 2008 and the Imports(as % of merchandise exports) in Peru in 2010?
Your response must be concise. -17.9. What is the difference between the Imports(as % of merchandise exports) of Pacific island small states in 2008 and the Imports(as % of merchandise exports) of Sub-Saharan Africa (developing only) in 2011?
Offer a very short reply. -16.97. What is the difference between the Imports(as % of merchandise exports) of Pacific island small states in 2008 and the Imports(as % of merchandise exports) of Greenland in 2011?
Offer a very short reply. -11.12. What is the difference between the Imports(as % of merchandise exports) of Pacific island small states in 2008 and the Imports(as % of merchandise exports) of Peru in 2011?
Provide a short and direct response. -27.01. What is the difference between the Imports(as % of merchandise exports) in Sub-Saharan Africa (developing only) in 2008 and the Imports(as % of merchandise exports) in Greenland in 2011?
Ensure brevity in your answer.  8.96. What is the difference between the Imports(as % of merchandise exports) in Sub-Saharan Africa (developing only) in 2008 and the Imports(as % of merchandise exports) in Peru in 2011?
Offer a very short reply. -6.93. What is the difference between the Imports(as % of merchandise exports) of Greenland in 2008 and the Imports(as % of merchandise exports) of Peru in 2011?
Your answer should be very brief. -16.66. What is the difference between the Imports(as % of merchandise exports) in Pacific island small states in 2008 and the Imports(as % of merchandise exports) in Sub-Saharan Africa (developing only) in 2012?
Provide a short and direct response. -18.33. What is the difference between the Imports(as % of merchandise exports) of Pacific island small states in 2008 and the Imports(as % of merchandise exports) of Greenland in 2012?
Your answer should be very brief. -6.79. What is the difference between the Imports(as % of merchandise exports) in Pacific island small states in 2008 and the Imports(as % of merchandise exports) in Peru in 2012?
Offer a very short reply. -28.84. What is the difference between the Imports(as % of merchandise exports) of Sub-Saharan Africa (developing only) in 2008 and the Imports(as % of merchandise exports) of Greenland in 2012?
Provide a succinct answer. 13.29. What is the difference between the Imports(as % of merchandise exports) of Sub-Saharan Africa (developing only) in 2008 and the Imports(as % of merchandise exports) of Peru in 2012?
Offer a terse response. -8.76. What is the difference between the Imports(as % of merchandise exports) of Greenland in 2008 and the Imports(as % of merchandise exports) of Peru in 2012?
Offer a terse response. -18.49. What is the difference between the Imports(as % of merchandise exports) of Pacific island small states in 2009 and the Imports(as % of merchandise exports) of Sub-Saharan Africa (developing only) in 2010?
Give a very brief answer. -17.71. What is the difference between the Imports(as % of merchandise exports) in Pacific island small states in 2009 and the Imports(as % of merchandise exports) in Greenland in 2010?
Provide a succinct answer. -6.98. What is the difference between the Imports(as % of merchandise exports) of Pacific island small states in 2009 and the Imports(as % of merchandise exports) of Peru in 2010?
Ensure brevity in your answer.  -23.22. What is the difference between the Imports(as % of merchandise exports) of Sub-Saharan Africa (developing only) in 2009 and the Imports(as % of merchandise exports) of Greenland in 2010?
Keep it short and to the point. 11.04. What is the difference between the Imports(as % of merchandise exports) of Sub-Saharan Africa (developing only) in 2009 and the Imports(as % of merchandise exports) of Peru in 2010?
Provide a short and direct response. -5.2. What is the difference between the Imports(as % of merchandise exports) of Greenland in 2009 and the Imports(as % of merchandise exports) of Peru in 2010?
Your response must be concise. -12.32. What is the difference between the Imports(as % of merchandise exports) of Pacific island small states in 2009 and the Imports(as % of merchandise exports) of Sub-Saharan Africa (developing only) in 2011?
Your response must be concise. -11.94. What is the difference between the Imports(as % of merchandise exports) of Pacific island small states in 2009 and the Imports(as % of merchandise exports) of Greenland in 2011?
Make the answer very short. -6.09. What is the difference between the Imports(as % of merchandise exports) of Pacific island small states in 2009 and the Imports(as % of merchandise exports) of Peru in 2011?
Make the answer very short. -21.98. What is the difference between the Imports(as % of merchandise exports) of Sub-Saharan Africa (developing only) in 2009 and the Imports(as % of merchandise exports) of Greenland in 2011?
Ensure brevity in your answer.  11.93. What is the difference between the Imports(as % of merchandise exports) in Sub-Saharan Africa (developing only) in 2009 and the Imports(as % of merchandise exports) in Peru in 2011?
Keep it short and to the point. -3.96. What is the difference between the Imports(as % of merchandise exports) of Greenland in 2009 and the Imports(as % of merchandise exports) of Peru in 2011?
Offer a very short reply. -11.08. What is the difference between the Imports(as % of merchandise exports) of Pacific island small states in 2009 and the Imports(as % of merchandise exports) of Sub-Saharan Africa (developing only) in 2012?
Your answer should be compact. -13.3. What is the difference between the Imports(as % of merchandise exports) in Pacific island small states in 2009 and the Imports(as % of merchandise exports) in Greenland in 2012?
Ensure brevity in your answer.  -1.76. What is the difference between the Imports(as % of merchandise exports) of Pacific island small states in 2009 and the Imports(as % of merchandise exports) of Peru in 2012?
Offer a terse response. -23.81. What is the difference between the Imports(as % of merchandise exports) of Sub-Saharan Africa (developing only) in 2009 and the Imports(as % of merchandise exports) of Greenland in 2012?
Keep it short and to the point. 16.26. What is the difference between the Imports(as % of merchandise exports) of Sub-Saharan Africa (developing only) in 2009 and the Imports(as % of merchandise exports) of Peru in 2012?
Your response must be concise. -5.79. What is the difference between the Imports(as % of merchandise exports) of Greenland in 2009 and the Imports(as % of merchandise exports) of Peru in 2012?
Ensure brevity in your answer.  -12.91. What is the difference between the Imports(as % of merchandise exports) of Pacific island small states in 2010 and the Imports(as % of merchandise exports) of Sub-Saharan Africa (developing only) in 2011?
Make the answer very short. -12.72. What is the difference between the Imports(as % of merchandise exports) of Pacific island small states in 2010 and the Imports(as % of merchandise exports) of Greenland in 2011?
Make the answer very short. -6.87. What is the difference between the Imports(as % of merchandise exports) in Pacific island small states in 2010 and the Imports(as % of merchandise exports) in Peru in 2011?
Your response must be concise. -22.76. What is the difference between the Imports(as % of merchandise exports) in Sub-Saharan Africa (developing only) in 2010 and the Imports(as % of merchandise exports) in Greenland in 2011?
Offer a terse response. 11.62. What is the difference between the Imports(as % of merchandise exports) of Sub-Saharan Africa (developing only) in 2010 and the Imports(as % of merchandise exports) of Peru in 2011?
Make the answer very short. -4.27. What is the difference between the Imports(as % of merchandise exports) in Greenland in 2010 and the Imports(as % of merchandise exports) in Peru in 2011?
Offer a terse response. -15. What is the difference between the Imports(as % of merchandise exports) of Pacific island small states in 2010 and the Imports(as % of merchandise exports) of Sub-Saharan Africa (developing only) in 2012?
Offer a very short reply. -14.08. What is the difference between the Imports(as % of merchandise exports) in Pacific island small states in 2010 and the Imports(as % of merchandise exports) in Greenland in 2012?
Provide a short and direct response. -2.54. What is the difference between the Imports(as % of merchandise exports) of Pacific island small states in 2010 and the Imports(as % of merchandise exports) of Peru in 2012?
Offer a very short reply. -24.59. What is the difference between the Imports(as % of merchandise exports) in Sub-Saharan Africa (developing only) in 2010 and the Imports(as % of merchandise exports) in Greenland in 2012?
Your response must be concise. 15.95. What is the difference between the Imports(as % of merchandise exports) of Greenland in 2010 and the Imports(as % of merchandise exports) of Peru in 2012?
Keep it short and to the point. -16.83. What is the difference between the Imports(as % of merchandise exports) in Pacific island small states in 2011 and the Imports(as % of merchandise exports) in Sub-Saharan Africa (developing only) in 2012?
Keep it short and to the point. -17.55. What is the difference between the Imports(as % of merchandise exports) in Pacific island small states in 2011 and the Imports(as % of merchandise exports) in Greenland in 2012?
Give a very brief answer. -6. What is the difference between the Imports(as % of merchandise exports) of Pacific island small states in 2011 and the Imports(as % of merchandise exports) of Peru in 2012?
Keep it short and to the point. -28.05. What is the difference between the Imports(as % of merchandise exports) in Sub-Saharan Africa (developing only) in 2011 and the Imports(as % of merchandise exports) in Greenland in 2012?
Your answer should be compact. 10.18. What is the difference between the Imports(as % of merchandise exports) in Sub-Saharan Africa (developing only) in 2011 and the Imports(as % of merchandise exports) in Peru in 2012?
Provide a succinct answer. -11.87. What is the difference between the Imports(as % of merchandise exports) in Greenland in 2011 and the Imports(as % of merchandise exports) in Peru in 2012?
Provide a short and direct response. -17.72. What is the average Imports(as % of merchandise exports) of Pacific island small states per year?
Offer a terse response. 47.03. What is the average Imports(as % of merchandise exports) of Sub-Saharan Africa (developing only) per year?
Offer a terse response. 64.86. What is the average Imports(as % of merchandise exports) in Greenland per year?
Provide a short and direct response. 57.06. What is the average Imports(as % of merchandise exports) of Peru per year?
Ensure brevity in your answer.  69.68. In the year 2005, what is the difference between the Imports(as % of merchandise exports) in Pacific island small states and Imports(as % of merchandise exports) in Sub-Saharan Africa (developing only)?
Offer a terse response. -15.68. In the year 2005, what is the difference between the Imports(as % of merchandise exports) in Pacific island small states and Imports(as % of merchandise exports) in Greenland?
Your response must be concise. -12.27. In the year 2005, what is the difference between the Imports(as % of merchandise exports) of Pacific island small states and Imports(as % of merchandise exports) of Peru?
Give a very brief answer. -15.86. In the year 2005, what is the difference between the Imports(as % of merchandise exports) in Sub-Saharan Africa (developing only) and Imports(as % of merchandise exports) in Greenland?
Offer a very short reply. 3.41. In the year 2005, what is the difference between the Imports(as % of merchandise exports) of Sub-Saharan Africa (developing only) and Imports(as % of merchandise exports) of Peru?
Provide a succinct answer. -0.18. In the year 2005, what is the difference between the Imports(as % of merchandise exports) of Greenland and Imports(as % of merchandise exports) of Peru?
Make the answer very short. -3.59. In the year 2006, what is the difference between the Imports(as % of merchandise exports) in Pacific island small states and Imports(as % of merchandise exports) in Sub-Saharan Africa (developing only)?
Provide a succinct answer. -16.54. In the year 2006, what is the difference between the Imports(as % of merchandise exports) of Pacific island small states and Imports(as % of merchandise exports) of Greenland?
Make the answer very short. -10.71. In the year 2006, what is the difference between the Imports(as % of merchandise exports) in Pacific island small states and Imports(as % of merchandise exports) in Peru?
Make the answer very short. -19.4. In the year 2006, what is the difference between the Imports(as % of merchandise exports) of Sub-Saharan Africa (developing only) and Imports(as % of merchandise exports) of Greenland?
Your answer should be very brief. 5.84. In the year 2006, what is the difference between the Imports(as % of merchandise exports) of Sub-Saharan Africa (developing only) and Imports(as % of merchandise exports) of Peru?
Your response must be concise. -2.86. In the year 2006, what is the difference between the Imports(as % of merchandise exports) of Greenland and Imports(as % of merchandise exports) of Peru?
Your answer should be compact. -8.7. In the year 2007, what is the difference between the Imports(as % of merchandise exports) in Pacific island small states and Imports(as % of merchandise exports) in Sub-Saharan Africa (developing only)?
Give a very brief answer. -21.12. In the year 2007, what is the difference between the Imports(as % of merchandise exports) in Pacific island small states and Imports(as % of merchandise exports) in Greenland?
Your response must be concise. -12.97. In the year 2007, what is the difference between the Imports(as % of merchandise exports) of Pacific island small states and Imports(as % of merchandise exports) of Peru?
Make the answer very short. -20.65. In the year 2007, what is the difference between the Imports(as % of merchandise exports) in Sub-Saharan Africa (developing only) and Imports(as % of merchandise exports) in Greenland?
Provide a short and direct response. 8.15. In the year 2007, what is the difference between the Imports(as % of merchandise exports) in Sub-Saharan Africa (developing only) and Imports(as % of merchandise exports) in Peru?
Offer a terse response. 0.47. In the year 2007, what is the difference between the Imports(as % of merchandise exports) in Greenland and Imports(as % of merchandise exports) in Peru?
Your answer should be compact. -7.69. In the year 2008, what is the difference between the Imports(as % of merchandise exports) in Pacific island small states and Imports(as % of merchandise exports) in Sub-Saharan Africa (developing only)?
Your response must be concise. -20.08. In the year 2008, what is the difference between the Imports(as % of merchandise exports) in Pacific island small states and Imports(as % of merchandise exports) in Greenland?
Provide a succinct answer. -10.35. In the year 2008, what is the difference between the Imports(as % of merchandise exports) in Pacific island small states and Imports(as % of merchandise exports) in Peru?
Your response must be concise. -24.88. In the year 2008, what is the difference between the Imports(as % of merchandise exports) of Sub-Saharan Africa (developing only) and Imports(as % of merchandise exports) of Greenland?
Provide a succinct answer. 9.73. In the year 2008, what is the difference between the Imports(as % of merchandise exports) in Sub-Saharan Africa (developing only) and Imports(as % of merchandise exports) in Peru?
Give a very brief answer. -4.8. In the year 2008, what is the difference between the Imports(as % of merchandise exports) of Greenland and Imports(as % of merchandise exports) of Peru?
Make the answer very short. -14.54. In the year 2009, what is the difference between the Imports(as % of merchandise exports) in Pacific island small states and Imports(as % of merchandise exports) in Sub-Saharan Africa (developing only)?
Offer a very short reply. -18.02. In the year 2009, what is the difference between the Imports(as % of merchandise exports) of Pacific island small states and Imports(as % of merchandise exports) of Greenland?
Keep it short and to the point. -10.9. In the year 2009, what is the difference between the Imports(as % of merchandise exports) in Pacific island small states and Imports(as % of merchandise exports) in Peru?
Ensure brevity in your answer.  -23.14. In the year 2009, what is the difference between the Imports(as % of merchandise exports) in Sub-Saharan Africa (developing only) and Imports(as % of merchandise exports) in Greenland?
Provide a short and direct response. 7.12. In the year 2009, what is the difference between the Imports(as % of merchandise exports) of Sub-Saharan Africa (developing only) and Imports(as % of merchandise exports) of Peru?
Give a very brief answer. -5.12. In the year 2009, what is the difference between the Imports(as % of merchandise exports) of Greenland and Imports(as % of merchandise exports) of Peru?
Make the answer very short. -12.24. In the year 2010, what is the difference between the Imports(as % of merchandise exports) of Pacific island small states and Imports(as % of merchandise exports) of Sub-Saharan Africa (developing only)?
Provide a succinct answer. -18.49. In the year 2010, what is the difference between the Imports(as % of merchandise exports) of Pacific island small states and Imports(as % of merchandise exports) of Greenland?
Provide a short and direct response. -7.76. In the year 2010, what is the difference between the Imports(as % of merchandise exports) of Pacific island small states and Imports(as % of merchandise exports) of Peru?
Give a very brief answer. -24. In the year 2010, what is the difference between the Imports(as % of merchandise exports) of Sub-Saharan Africa (developing only) and Imports(as % of merchandise exports) of Greenland?
Give a very brief answer. 10.73. In the year 2010, what is the difference between the Imports(as % of merchandise exports) of Sub-Saharan Africa (developing only) and Imports(as % of merchandise exports) of Peru?
Your answer should be compact. -5.51. In the year 2010, what is the difference between the Imports(as % of merchandise exports) in Greenland and Imports(as % of merchandise exports) in Peru?
Give a very brief answer. -16.24. In the year 2011, what is the difference between the Imports(as % of merchandise exports) of Pacific island small states and Imports(as % of merchandise exports) of Sub-Saharan Africa (developing only)?
Your answer should be compact. -16.18. In the year 2011, what is the difference between the Imports(as % of merchandise exports) in Pacific island small states and Imports(as % of merchandise exports) in Greenland?
Your answer should be very brief. -10.34. In the year 2011, what is the difference between the Imports(as % of merchandise exports) in Pacific island small states and Imports(as % of merchandise exports) in Peru?
Offer a very short reply. -26.22. In the year 2011, what is the difference between the Imports(as % of merchandise exports) in Sub-Saharan Africa (developing only) and Imports(as % of merchandise exports) in Greenland?
Your response must be concise. 5.85. In the year 2011, what is the difference between the Imports(as % of merchandise exports) of Sub-Saharan Africa (developing only) and Imports(as % of merchandise exports) of Peru?
Your answer should be compact. -10.04. In the year 2011, what is the difference between the Imports(as % of merchandise exports) in Greenland and Imports(as % of merchandise exports) in Peru?
Offer a terse response. -15.89. In the year 2012, what is the difference between the Imports(as % of merchandise exports) in Pacific island small states and Imports(as % of merchandise exports) in Sub-Saharan Africa (developing only)?
Offer a terse response. -16.5. In the year 2012, what is the difference between the Imports(as % of merchandise exports) in Pacific island small states and Imports(as % of merchandise exports) in Greenland?
Provide a succinct answer. -4.96. In the year 2012, what is the difference between the Imports(as % of merchandise exports) in Pacific island small states and Imports(as % of merchandise exports) in Peru?
Provide a short and direct response. -27.01. In the year 2012, what is the difference between the Imports(as % of merchandise exports) of Sub-Saharan Africa (developing only) and Imports(as % of merchandise exports) of Greenland?
Provide a short and direct response. 11.55. In the year 2012, what is the difference between the Imports(as % of merchandise exports) in Sub-Saharan Africa (developing only) and Imports(as % of merchandise exports) in Peru?
Your response must be concise. -10.51. In the year 2012, what is the difference between the Imports(as % of merchandise exports) of Greenland and Imports(as % of merchandise exports) of Peru?
Give a very brief answer. -22.05. What is the ratio of the Imports(as % of merchandise exports) in Pacific island small states in 2005 to that in 2006?
Make the answer very short. 1.03. What is the ratio of the Imports(as % of merchandise exports) of Sub-Saharan Africa (developing only) in 2005 to that in 2006?
Provide a short and direct response. 1.01. What is the ratio of the Imports(as % of merchandise exports) in Greenland in 2005 to that in 2006?
Your answer should be very brief. 1.05. What is the ratio of the Imports(as % of merchandise exports) of Peru in 2005 to that in 2006?
Offer a very short reply. 0.97. What is the ratio of the Imports(as % of merchandise exports) in Pacific island small states in 2005 to that in 2007?
Your answer should be very brief. 1.12. What is the ratio of the Imports(as % of merchandise exports) of Sub-Saharan Africa (developing only) in 2005 to that in 2007?
Provide a short and direct response. 1. What is the ratio of the Imports(as % of merchandise exports) of Greenland in 2005 to that in 2007?
Offer a terse response. 1.08. What is the ratio of the Imports(as % of merchandise exports) in Pacific island small states in 2005 to that in 2008?
Ensure brevity in your answer.  1.13. What is the ratio of the Imports(as % of merchandise exports) in Sub-Saharan Africa (developing only) in 2005 to that in 2008?
Make the answer very short. 1.02. What is the ratio of the Imports(as % of merchandise exports) of Greenland in 2005 to that in 2008?
Your response must be concise. 1.14. What is the ratio of the Imports(as % of merchandise exports) in Peru in 2005 to that in 2008?
Your answer should be very brief. 0.96. What is the ratio of the Imports(as % of merchandise exports) of Pacific island small states in 2005 to that in 2009?
Give a very brief answer. 1.02. What is the ratio of the Imports(as % of merchandise exports) of Sub-Saharan Africa (developing only) in 2005 to that in 2009?
Your answer should be very brief. 0.98. What is the ratio of the Imports(as % of merchandise exports) in Greenland in 2005 to that in 2009?
Make the answer very short. 1.04. What is the ratio of the Imports(as % of merchandise exports) in Peru in 2005 to that in 2009?
Offer a very short reply. 0.91. What is the ratio of the Imports(as % of merchandise exports) in Pacific island small states in 2005 to that in 2010?
Give a very brief answer. 1.03. What is the ratio of the Imports(as % of merchandise exports) in Greenland in 2005 to that in 2010?
Provide a short and direct response. 1.11. What is the ratio of the Imports(as % of merchandise exports) of Peru in 2005 to that in 2010?
Offer a very short reply. 0.91. What is the ratio of the Imports(as % of merchandise exports) in Pacific island small states in 2005 to that in 2011?
Your answer should be compact. 1.11. What is the ratio of the Imports(as % of merchandise exports) of Sub-Saharan Africa (developing only) in 2005 to that in 2011?
Your response must be concise. 1.08. What is the ratio of the Imports(as % of merchandise exports) of Greenland in 2005 to that in 2011?
Provide a succinct answer. 1.13. What is the ratio of the Imports(as % of merchandise exports) of Peru in 2005 to that in 2011?
Provide a succinct answer. 0.93. What is the ratio of the Imports(as % of merchandise exports) in Pacific island small states in 2005 to that in 2012?
Ensure brevity in your answer.  1.09. What is the ratio of the Imports(as % of merchandise exports) of Sub-Saharan Africa (developing only) in 2005 to that in 2012?
Your response must be concise. 1.05. What is the ratio of the Imports(as % of merchandise exports) in Greenland in 2005 to that in 2012?
Provide a short and direct response. 1.22. What is the ratio of the Imports(as % of merchandise exports) in Peru in 2005 to that in 2012?
Offer a terse response. 0.9. What is the ratio of the Imports(as % of merchandise exports) in Pacific island small states in 2006 to that in 2007?
Offer a terse response. 1.08. What is the ratio of the Imports(as % of merchandise exports) of Greenland in 2006 to that in 2007?
Offer a very short reply. 1.03. What is the ratio of the Imports(as % of merchandise exports) in Peru in 2006 to that in 2007?
Provide a short and direct response. 1.04. What is the ratio of the Imports(as % of merchandise exports) of Pacific island small states in 2006 to that in 2008?
Your answer should be compact. 1.1. What is the ratio of the Imports(as % of merchandise exports) in Sub-Saharan Africa (developing only) in 2006 to that in 2008?
Your answer should be compact. 1.01. What is the ratio of the Imports(as % of merchandise exports) in Greenland in 2006 to that in 2008?
Your response must be concise. 1.08. What is the ratio of the Imports(as % of merchandise exports) in Peru in 2006 to that in 2008?
Your answer should be very brief. 0.98. What is the ratio of the Imports(as % of merchandise exports) in Pacific island small states in 2006 to that in 2009?
Give a very brief answer. 0.98. What is the ratio of the Imports(as % of merchandise exports) of Sub-Saharan Africa (developing only) in 2006 to that in 2009?
Your response must be concise. 0.97. What is the ratio of the Imports(as % of merchandise exports) of Greenland in 2006 to that in 2009?
Provide a short and direct response. 0.98. What is the ratio of the Imports(as % of merchandise exports) in Peru in 2006 to that in 2009?
Your answer should be compact. 0.94. What is the ratio of the Imports(as % of merchandise exports) of Pacific island small states in 2006 to that in 2010?
Your answer should be compact. 1. What is the ratio of the Imports(as % of merchandise exports) of Sub-Saharan Africa (developing only) in 2006 to that in 2010?
Your response must be concise. 0.97. What is the ratio of the Imports(as % of merchandise exports) in Greenland in 2006 to that in 2010?
Provide a short and direct response. 1.05. What is the ratio of the Imports(as % of merchandise exports) of Peru in 2006 to that in 2010?
Offer a terse response. 0.94. What is the ratio of the Imports(as % of merchandise exports) of Pacific island small states in 2006 to that in 2011?
Ensure brevity in your answer.  1.08. What is the ratio of the Imports(as % of merchandise exports) of Sub-Saharan Africa (developing only) in 2006 to that in 2011?
Provide a succinct answer. 1.06. What is the ratio of the Imports(as % of merchandise exports) in Greenland in 2006 to that in 2011?
Offer a very short reply. 1.07. What is the ratio of the Imports(as % of merchandise exports) in Peru in 2006 to that in 2011?
Give a very brief answer. 0.95. What is the ratio of the Imports(as % of merchandise exports) in Pacific island small states in 2006 to that in 2012?
Make the answer very short. 1.05. What is the ratio of the Imports(as % of merchandise exports) of Sub-Saharan Africa (developing only) in 2006 to that in 2012?
Offer a very short reply. 1.04. What is the ratio of the Imports(as % of merchandise exports) of Greenland in 2006 to that in 2012?
Give a very brief answer. 1.16. What is the ratio of the Imports(as % of merchandise exports) in Peru in 2006 to that in 2012?
Provide a short and direct response. 0.93. What is the ratio of the Imports(as % of merchandise exports) of Pacific island small states in 2007 to that in 2008?
Provide a succinct answer. 1.01. What is the ratio of the Imports(as % of merchandise exports) in Sub-Saharan Africa (developing only) in 2007 to that in 2008?
Ensure brevity in your answer.  1.02. What is the ratio of the Imports(as % of merchandise exports) of Greenland in 2007 to that in 2008?
Ensure brevity in your answer.  1.06. What is the ratio of the Imports(as % of merchandise exports) of Peru in 2007 to that in 2008?
Keep it short and to the point. 0.95. What is the ratio of the Imports(as % of merchandise exports) in Pacific island small states in 2007 to that in 2009?
Offer a terse response. 0.91. What is the ratio of the Imports(as % of merchandise exports) in Sub-Saharan Africa (developing only) in 2007 to that in 2009?
Keep it short and to the point. 0.98. What is the ratio of the Imports(as % of merchandise exports) of Greenland in 2007 to that in 2009?
Offer a very short reply. 0.96. What is the ratio of the Imports(as % of merchandise exports) of Peru in 2007 to that in 2009?
Your answer should be compact. 0.9. What is the ratio of the Imports(as % of merchandise exports) in Pacific island small states in 2007 to that in 2010?
Ensure brevity in your answer.  0.92. What is the ratio of the Imports(as % of merchandise exports) of Sub-Saharan Africa (developing only) in 2007 to that in 2010?
Offer a very short reply. 0.98. What is the ratio of the Imports(as % of merchandise exports) in Greenland in 2007 to that in 2010?
Give a very brief answer. 1.03. What is the ratio of the Imports(as % of merchandise exports) in Peru in 2007 to that in 2010?
Offer a very short reply. 0.9. What is the ratio of the Imports(as % of merchandise exports) of Pacific island small states in 2007 to that in 2011?
Offer a very short reply. 0.99. What is the ratio of the Imports(as % of merchandise exports) of Sub-Saharan Africa (developing only) in 2007 to that in 2011?
Your response must be concise. 1.08. What is the ratio of the Imports(as % of merchandise exports) of Greenland in 2007 to that in 2011?
Make the answer very short. 1.04. What is the ratio of the Imports(as % of merchandise exports) of Peru in 2007 to that in 2011?
Give a very brief answer. 0.92. What is the ratio of the Imports(as % of merchandise exports) of Pacific island small states in 2007 to that in 2012?
Ensure brevity in your answer.  0.97. What is the ratio of the Imports(as % of merchandise exports) in Sub-Saharan Africa (developing only) in 2007 to that in 2012?
Provide a short and direct response. 1.05. What is the ratio of the Imports(as % of merchandise exports) in Greenland in 2007 to that in 2012?
Keep it short and to the point. 1.13. What is the ratio of the Imports(as % of merchandise exports) in Peru in 2007 to that in 2012?
Provide a short and direct response. 0.89. What is the ratio of the Imports(as % of merchandise exports) of Pacific island small states in 2008 to that in 2009?
Offer a terse response. 0.9. What is the ratio of the Imports(as % of merchandise exports) of Sub-Saharan Africa (developing only) in 2008 to that in 2009?
Offer a terse response. 0.96. What is the ratio of the Imports(as % of merchandise exports) of Greenland in 2008 to that in 2009?
Make the answer very short. 0.91. What is the ratio of the Imports(as % of merchandise exports) of Peru in 2008 to that in 2009?
Offer a very short reply. 0.95. What is the ratio of the Imports(as % of merchandise exports) in Pacific island small states in 2008 to that in 2010?
Give a very brief answer. 0.91. What is the ratio of the Imports(as % of merchandise exports) of Sub-Saharan Africa (developing only) in 2008 to that in 2010?
Provide a succinct answer. 0.96. What is the ratio of the Imports(as % of merchandise exports) in Greenland in 2008 to that in 2010?
Ensure brevity in your answer.  0.97. What is the ratio of the Imports(as % of merchandise exports) in Peru in 2008 to that in 2010?
Provide a short and direct response. 0.95. What is the ratio of the Imports(as % of merchandise exports) in Pacific island small states in 2008 to that in 2011?
Offer a very short reply. 0.98. What is the ratio of the Imports(as % of merchandise exports) in Sub-Saharan Africa (developing only) in 2008 to that in 2011?
Ensure brevity in your answer.  1.05. What is the ratio of the Imports(as % of merchandise exports) in Peru in 2008 to that in 2011?
Your answer should be compact. 0.97. What is the ratio of the Imports(as % of merchandise exports) of Pacific island small states in 2008 to that in 2012?
Give a very brief answer. 0.96. What is the ratio of the Imports(as % of merchandise exports) in Sub-Saharan Africa (developing only) in 2008 to that in 2012?
Your response must be concise. 1.03. What is the ratio of the Imports(as % of merchandise exports) in Greenland in 2008 to that in 2012?
Provide a short and direct response. 1.07. What is the ratio of the Imports(as % of merchandise exports) in Peru in 2008 to that in 2012?
Your response must be concise. 0.95. What is the ratio of the Imports(as % of merchandise exports) in Pacific island small states in 2009 to that in 2010?
Your answer should be very brief. 1.02. What is the ratio of the Imports(as % of merchandise exports) in Greenland in 2009 to that in 2010?
Provide a short and direct response. 1.07. What is the ratio of the Imports(as % of merchandise exports) of Peru in 2009 to that in 2010?
Ensure brevity in your answer.  1. What is the ratio of the Imports(as % of merchandise exports) in Pacific island small states in 2009 to that in 2011?
Ensure brevity in your answer.  1.09. What is the ratio of the Imports(as % of merchandise exports) in Sub-Saharan Africa (developing only) in 2009 to that in 2011?
Offer a very short reply. 1.1. What is the ratio of the Imports(as % of merchandise exports) in Greenland in 2009 to that in 2011?
Provide a succinct answer. 1.09. What is the ratio of the Imports(as % of merchandise exports) of Peru in 2009 to that in 2011?
Your response must be concise. 1.02. What is the ratio of the Imports(as % of merchandise exports) of Pacific island small states in 2009 to that in 2012?
Ensure brevity in your answer.  1.07. What is the ratio of the Imports(as % of merchandise exports) in Sub-Saharan Africa (developing only) in 2009 to that in 2012?
Make the answer very short. 1.08. What is the ratio of the Imports(as % of merchandise exports) in Greenland in 2009 to that in 2012?
Your answer should be compact. 1.18. What is the ratio of the Imports(as % of merchandise exports) in Peru in 2009 to that in 2012?
Offer a terse response. 0.99. What is the ratio of the Imports(as % of merchandise exports) of Pacific island small states in 2010 to that in 2011?
Provide a short and direct response. 1.08. What is the ratio of the Imports(as % of merchandise exports) of Sub-Saharan Africa (developing only) in 2010 to that in 2011?
Provide a succinct answer. 1.09. What is the ratio of the Imports(as % of merchandise exports) of Greenland in 2010 to that in 2011?
Keep it short and to the point. 1.02. What is the ratio of the Imports(as % of merchandise exports) in Peru in 2010 to that in 2011?
Your answer should be compact. 1.02. What is the ratio of the Imports(as % of merchandise exports) of Pacific island small states in 2010 to that in 2012?
Offer a terse response. 1.05. What is the ratio of the Imports(as % of merchandise exports) of Sub-Saharan Africa (developing only) in 2010 to that in 2012?
Keep it short and to the point. 1.07. What is the ratio of the Imports(as % of merchandise exports) in Greenland in 2010 to that in 2012?
Provide a succinct answer. 1.1. What is the ratio of the Imports(as % of merchandise exports) of Pacific island small states in 2011 to that in 2012?
Give a very brief answer. 0.98. What is the ratio of the Imports(as % of merchandise exports) of Sub-Saharan Africa (developing only) in 2011 to that in 2012?
Offer a terse response. 0.98. What is the ratio of the Imports(as % of merchandise exports) in Greenland in 2011 to that in 2012?
Give a very brief answer. 1.08. What is the ratio of the Imports(as % of merchandise exports) of Peru in 2011 to that in 2012?
Provide a short and direct response. 0.97. What is the difference between the highest and the second highest Imports(as % of merchandise exports) of Pacific island small states?
Your answer should be very brief. 0.89. What is the difference between the highest and the second highest Imports(as % of merchandise exports) in Sub-Saharan Africa (developing only)?
Provide a short and direct response. 0.31. What is the difference between the highest and the second highest Imports(as % of merchandise exports) of Greenland?
Provide a succinct answer. 2.26. What is the difference between the highest and the second highest Imports(as % of merchandise exports) in Peru?
Keep it short and to the point. 0.59. What is the difference between the highest and the lowest Imports(as % of merchandise exports) of Pacific island small states?
Keep it short and to the point. 5.92. What is the difference between the highest and the lowest Imports(as % of merchandise exports) of Sub-Saharan Africa (developing only)?
Offer a very short reply. 6.08. What is the difference between the highest and the lowest Imports(as % of merchandise exports) of Greenland?
Offer a very short reply. 11.41. What is the difference between the highest and the lowest Imports(as % of merchandise exports) in Peru?
Give a very brief answer. 7.71. 